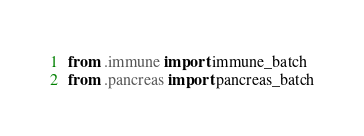Convert code to text. <code><loc_0><loc_0><loc_500><loc_500><_Python_>from .immune import immune_batch
from .pancreas import pancreas_batch
</code> 